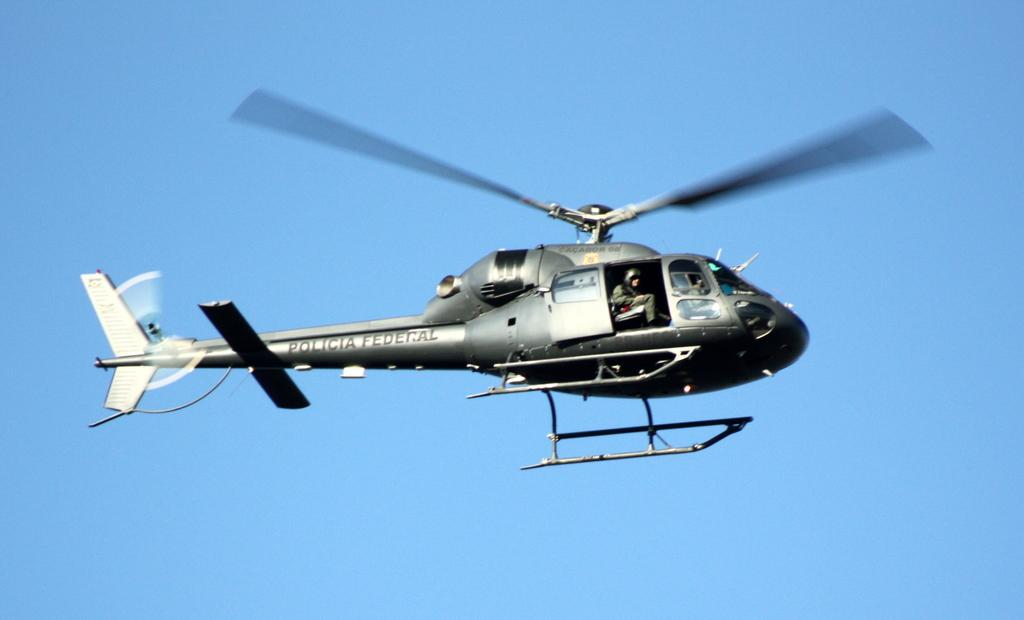What is the main subject of the image? The main subject of the image is a helicopter. Can you describe the position of the helicopter in the image? The helicopter is in the air in the image. Is there anyone inside the helicopter? Yes, there is a person seated in the helicopter. How long does the beam of light last in the image? There is no beam of light present in the image. What type of trail can be seen behind the helicopter in the image? There is no trail visible behind the helicopter in the image. 